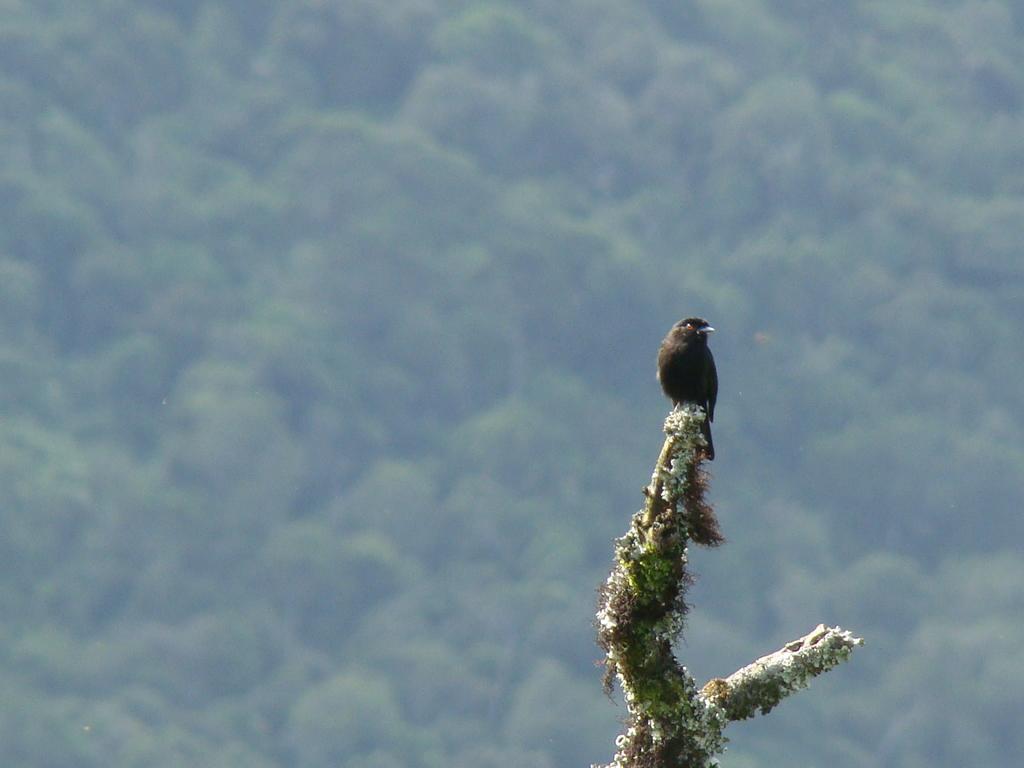How would you summarize this image in a sentence or two? In the center of the image there is a bird on the tree. In the background we can see trees. 